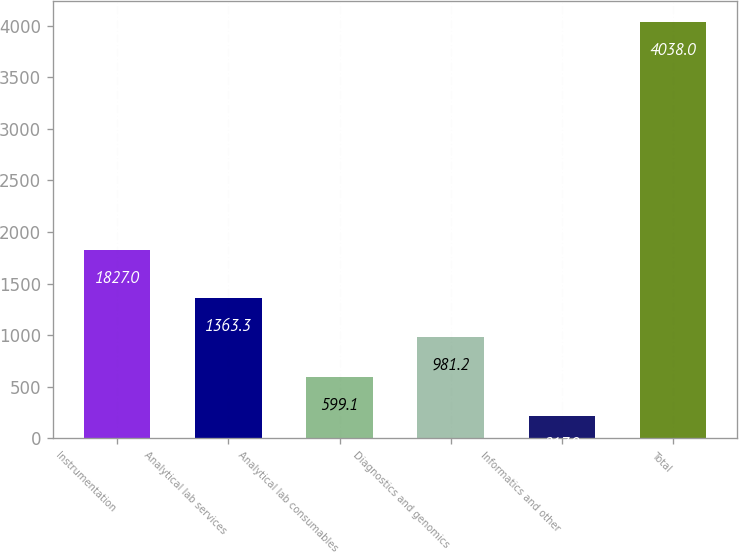Convert chart to OTSL. <chart><loc_0><loc_0><loc_500><loc_500><bar_chart><fcel>Instrumentation<fcel>Analytical lab services<fcel>Analytical lab consumables<fcel>Diagnostics and genomics<fcel>Informatics and other<fcel>Total<nl><fcel>1827<fcel>1363.3<fcel>599.1<fcel>981.2<fcel>217<fcel>4038<nl></chart> 